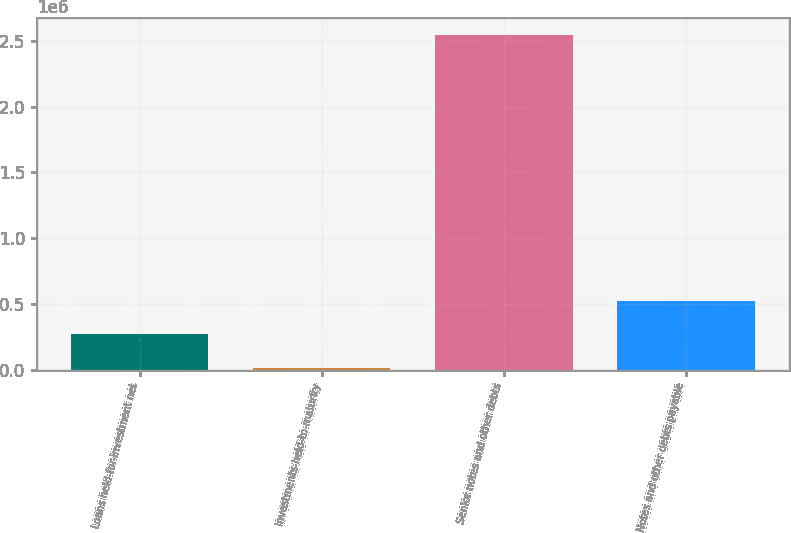Convert chart. <chart><loc_0><loc_0><loc_500><loc_500><bar_chart><fcel>Loans held-for-investment net<fcel>Investments-held-to-maturity<fcel>Senior notes and other debts<fcel>Notes and other debts payable<nl><fcel>271719<fcel>19139<fcel>2.54494e+06<fcel>524298<nl></chart> 